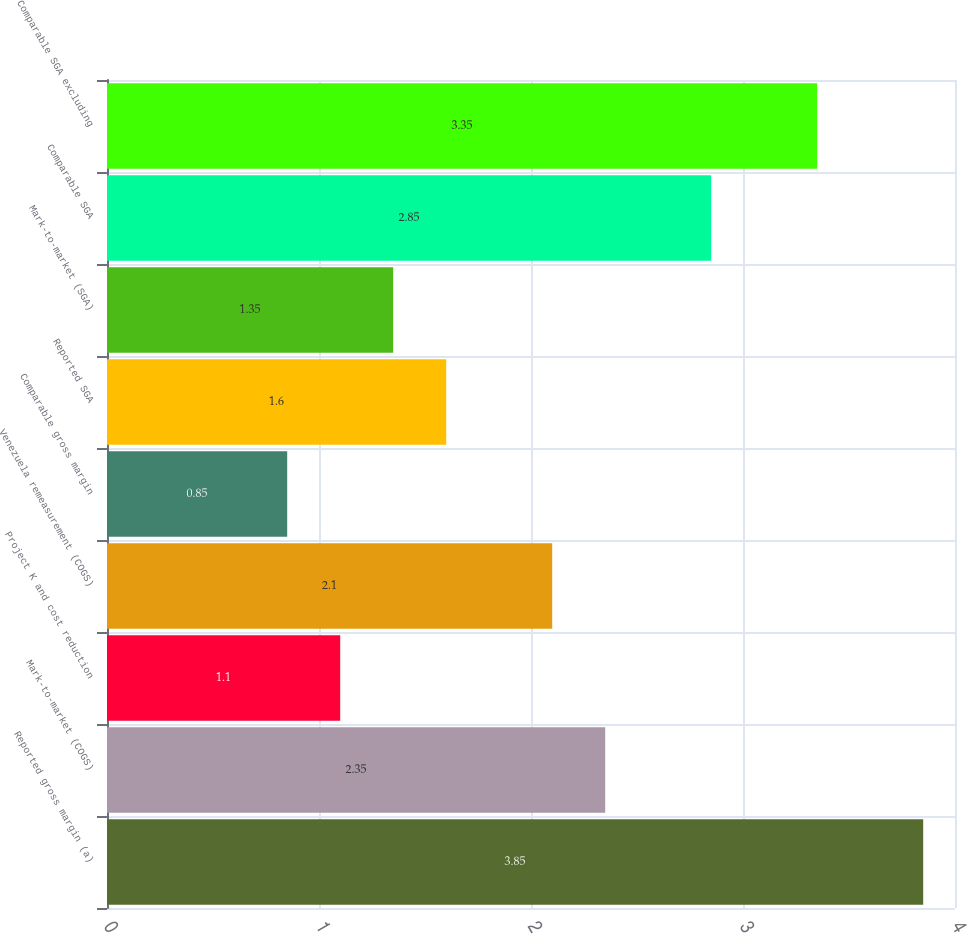Convert chart. <chart><loc_0><loc_0><loc_500><loc_500><bar_chart><fcel>Reported gross margin (a)<fcel>Mark-to-market (COGS)<fcel>Project K and cost reduction<fcel>Venezuela remeasurement (COGS)<fcel>Comparable gross margin<fcel>Reported SGA<fcel>Mark-to-market (SGA)<fcel>Comparable SGA<fcel>Comparable SGA excluding<nl><fcel>3.85<fcel>2.35<fcel>1.1<fcel>2.1<fcel>0.85<fcel>1.6<fcel>1.35<fcel>2.85<fcel>3.35<nl></chart> 